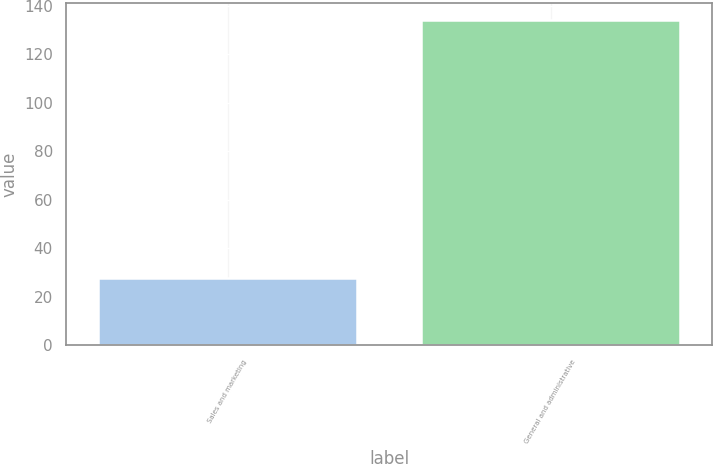Convert chart to OTSL. <chart><loc_0><loc_0><loc_500><loc_500><bar_chart><fcel>Sales and marketing<fcel>General and administrative<nl><fcel>27.8<fcel>134.2<nl></chart> 